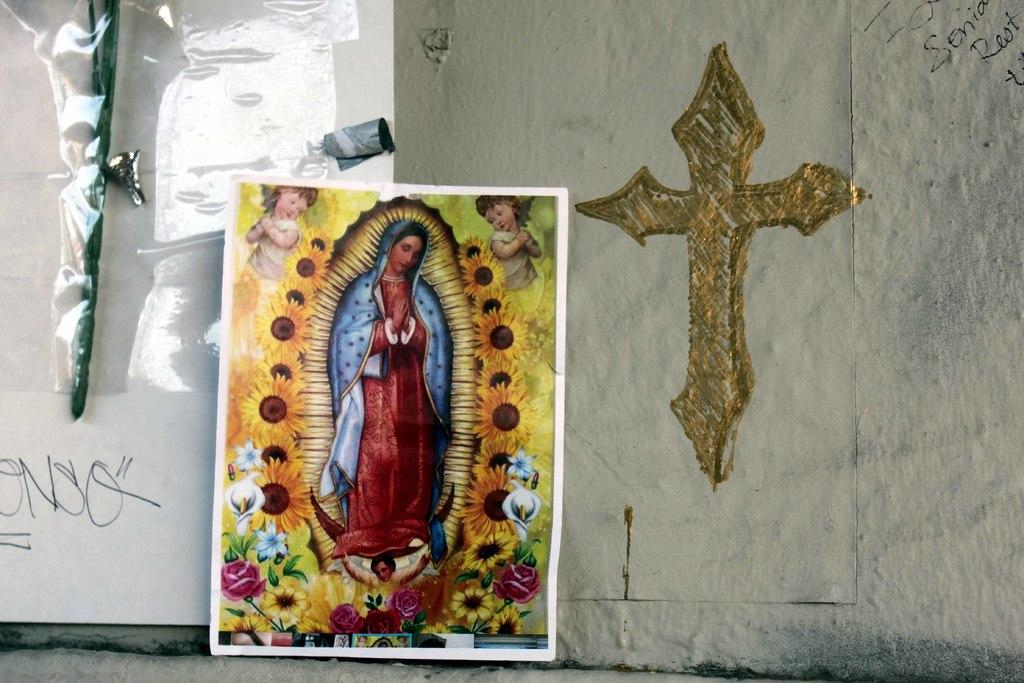<image>
Relay a brief, clear account of the picture shown. Blessed Mother Mary in a photo frame, with a cross on a wall. 